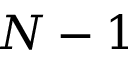<formula> <loc_0><loc_0><loc_500><loc_500>N - 1</formula> 